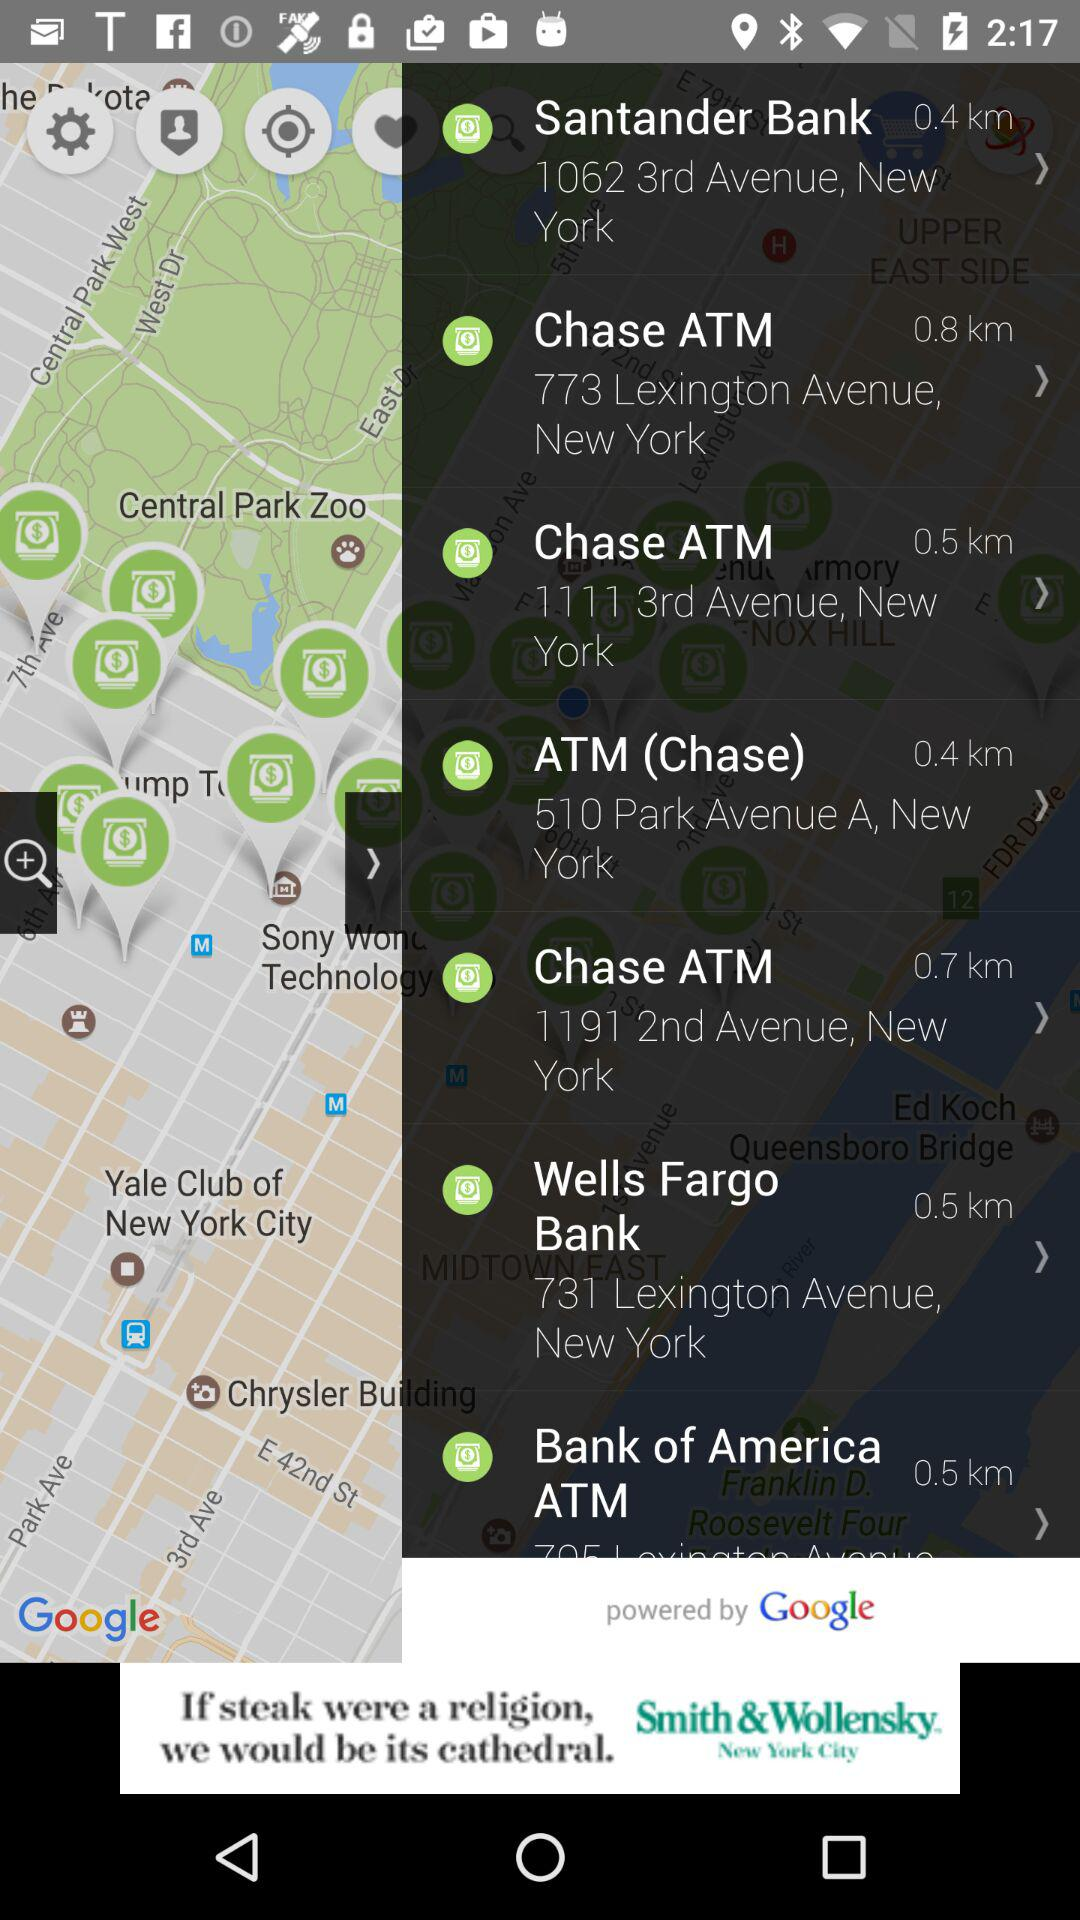Where can I find an ATM in 3rd Avenue? You can find an ATM in 3rd Avenue at 1062 3rd Avenue, New York and 1111 3rd Avenue, New York. 